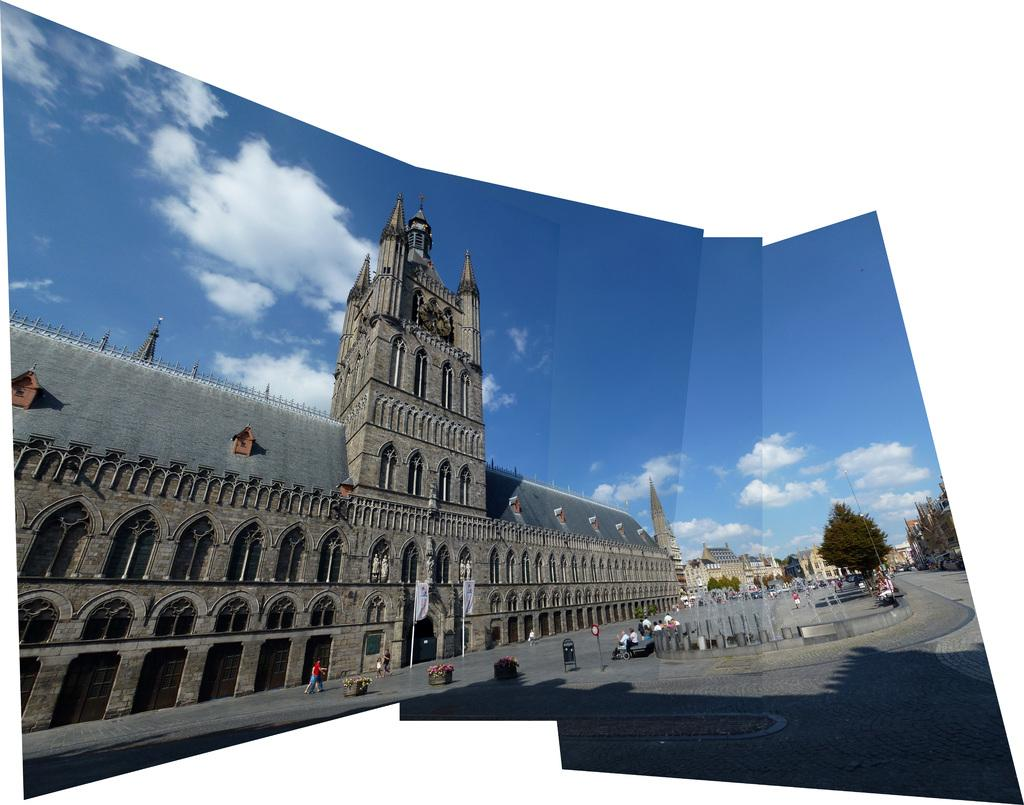What architectural feature can be seen in the image? There is a steeple in the image. What can be seen through the window in the image? The window in the image provides a view of the surroundings. Who or what is present in the image? There are people in the image. What water feature is visible in the image? There is a fountain in the image. What is the source of the water visible in the image? The water is coming from the fountain. What type of vegetation is present in the image? There are trees in the image. What type of structures are visible in the image? There are buildings in the image. What part of the natural environment is visible in the image? The sky is visible in the image. What atmospheric conditions can be observed in the sky? There are clouds in the image. Can you see a branch from the wren's nest in the image? There is no mention of a wren or its nest in the image, so it is not possible to see a branch from the wren's nest. 